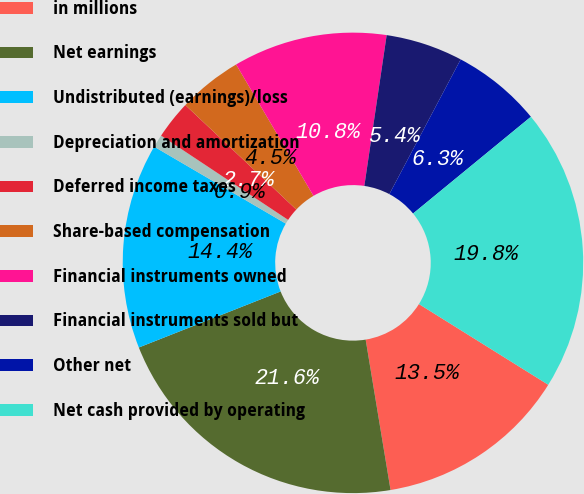<chart> <loc_0><loc_0><loc_500><loc_500><pie_chart><fcel>in millions<fcel>Net earnings<fcel>Undistributed (earnings)/loss<fcel>Depreciation and amortization<fcel>Deferred income taxes<fcel>Share-based compensation<fcel>Financial instruments owned<fcel>Financial instruments sold but<fcel>Other net<fcel>Net cash provided by operating<nl><fcel>13.51%<fcel>21.62%<fcel>14.41%<fcel>0.9%<fcel>2.7%<fcel>4.51%<fcel>10.81%<fcel>5.41%<fcel>6.31%<fcel>19.82%<nl></chart> 